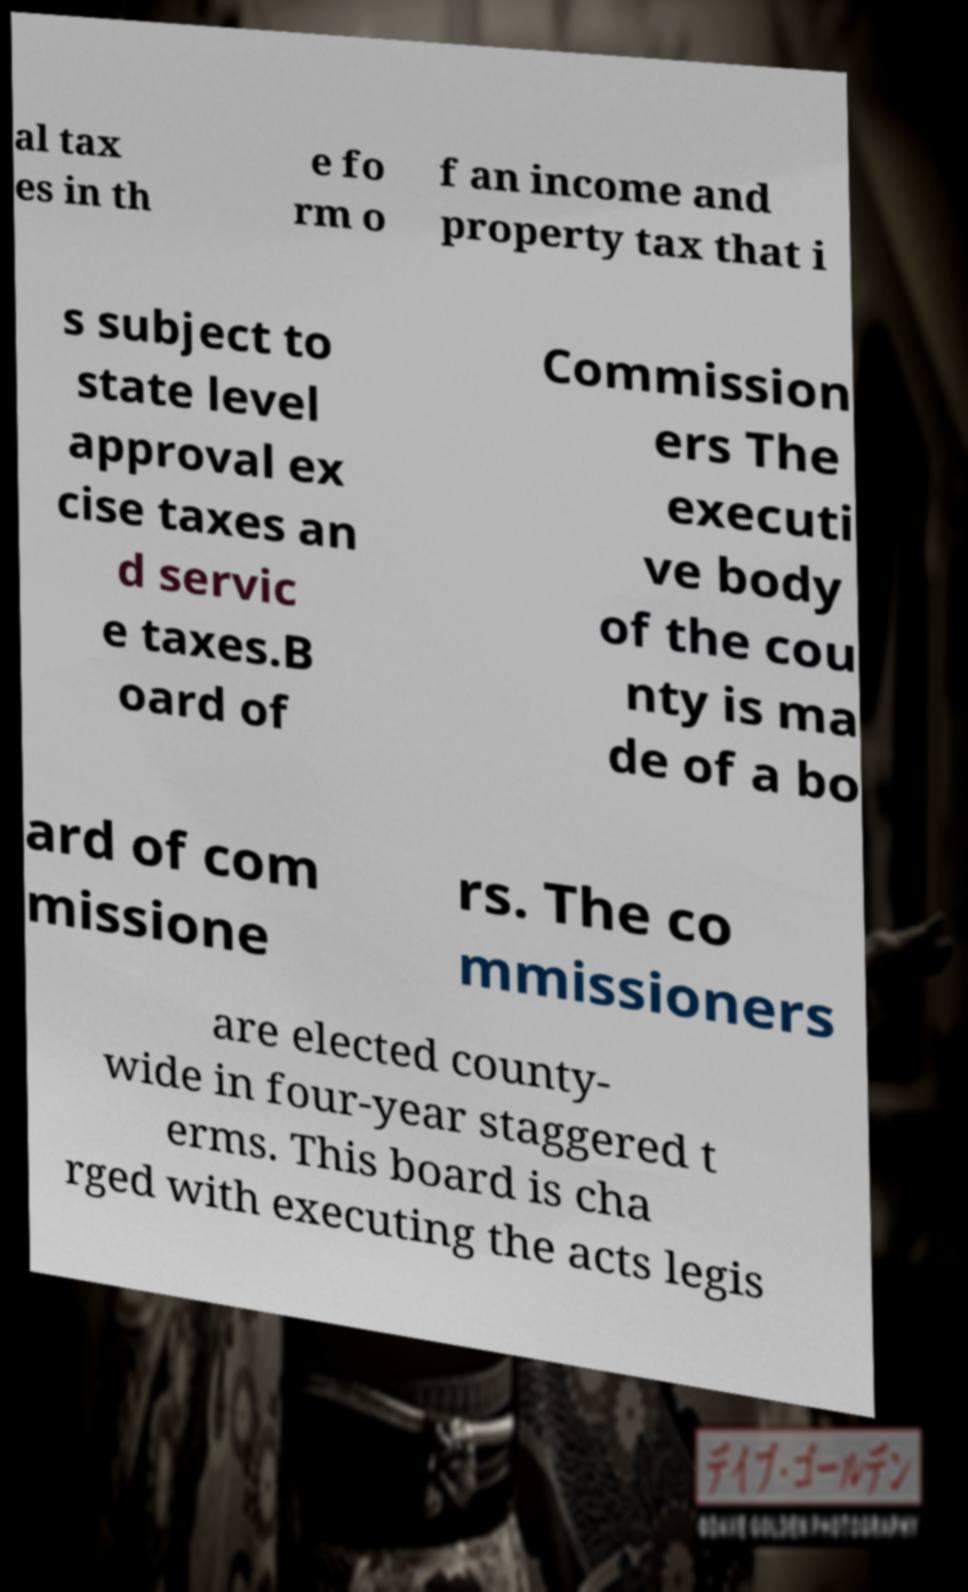Please identify and transcribe the text found in this image. al tax es in th e fo rm o f an income and property tax that i s subject to state level approval ex cise taxes an d servic e taxes.B oard of Commission ers The executi ve body of the cou nty is ma de of a bo ard of com missione rs. The co mmissioners are elected county- wide in four-year staggered t erms. This board is cha rged with executing the acts legis 